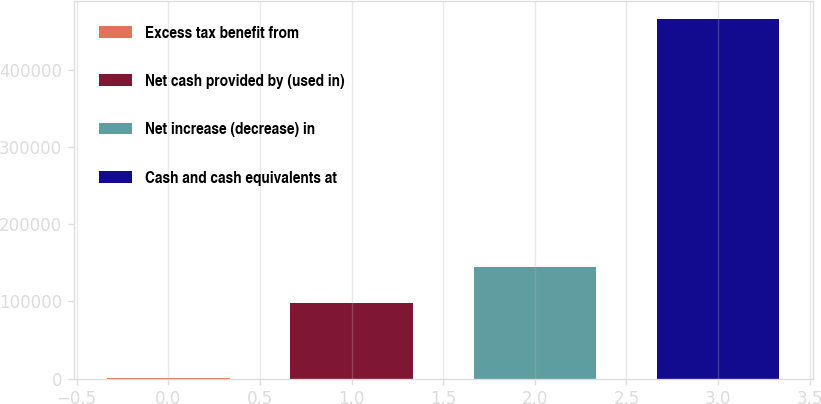<chart> <loc_0><loc_0><loc_500><loc_500><bar_chart><fcel>Excess tax benefit from<fcel>Net cash provided by (used in)<fcel>Net increase (decrease) in<fcel>Cash and cash equivalents at<nl><fcel>1216<fcel>98548<fcel>145087<fcel>466603<nl></chart> 